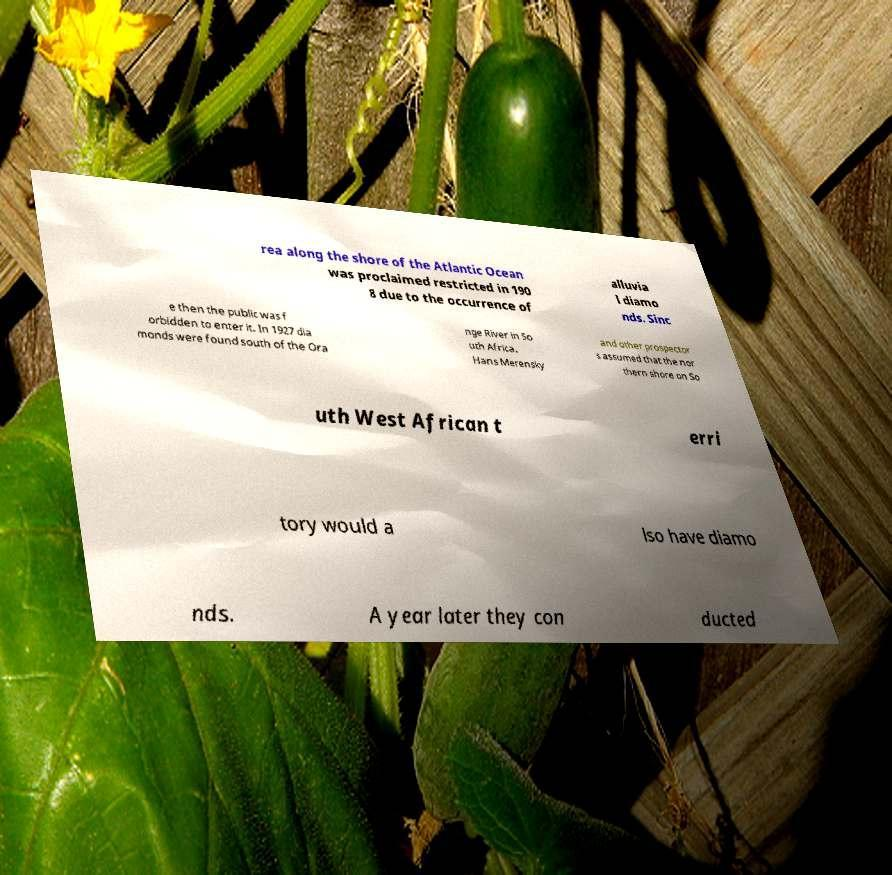Could you assist in decoding the text presented in this image and type it out clearly? rea along the shore of the Atlantic Ocean was proclaimed restricted in 190 8 due to the occurrence of alluvia l diamo nds. Sinc e then the public was f orbidden to enter it. In 1927 dia monds were found south of the Ora nge River in So uth Africa. Hans Merensky and other prospector s assumed that the nor thern shore on So uth West African t erri tory would a lso have diamo nds. A year later they con ducted 